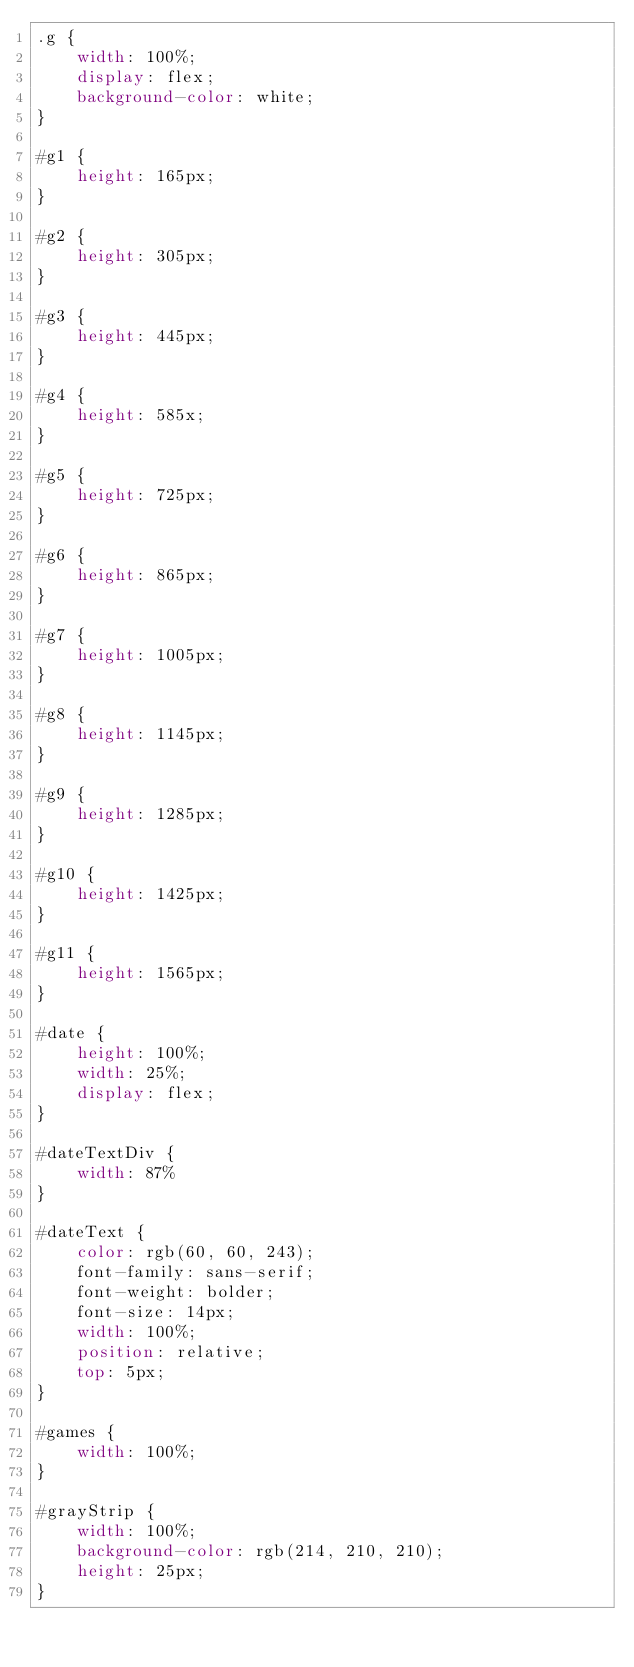Convert code to text. <code><loc_0><loc_0><loc_500><loc_500><_CSS_>.g {
    width: 100%;
    display: flex;
    background-color: white;
}

#g1 {
    height: 165px;
}

#g2 {
    height: 305px;
}

#g3 {
    height: 445px;
}

#g4 {
    height: 585x;
}

#g5 {
    height: 725px;
}

#g6 {
    height: 865px;
}

#g7 {
    height: 1005px;
}

#g8 {
    height: 1145px;
}

#g9 {
    height: 1285px;
}

#g10 {
    height: 1425px;
}

#g11 {
    height: 1565px;
}

#date {
    height: 100%;
    width: 25%;
    display: flex;
}

#dateTextDiv {
    width: 87%
}

#dateText {
    color: rgb(60, 60, 243);
    font-family: sans-serif;
    font-weight: bolder;
    font-size: 14px;
    width: 100%;
    position: relative;
    top: 5px;
}

#games {
    width: 100%;
}

#grayStrip {
    width: 100%;
    background-color: rgb(214, 210, 210);
    height: 25px;
}</code> 